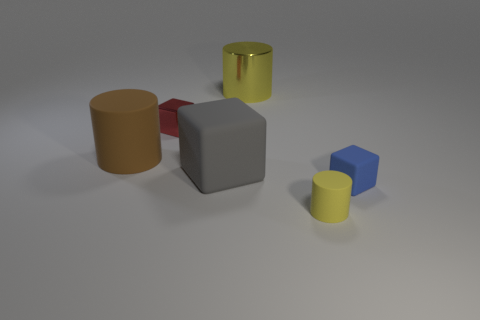Subtract all tiny rubber blocks. How many blocks are left? 2 Subtract all yellow cylinders. How many cylinders are left? 1 Add 3 big purple shiny things. How many objects exist? 9 Subtract all brown cylinders. How many red cubes are left? 1 Add 5 large gray matte balls. How many large gray matte balls exist? 5 Subtract 0 blue balls. How many objects are left? 6 Subtract 2 cylinders. How many cylinders are left? 1 Subtract all red cylinders. Subtract all blue cubes. How many cylinders are left? 3 Subtract all tiny metallic objects. Subtract all cubes. How many objects are left? 2 Add 3 large matte objects. How many large matte objects are left? 5 